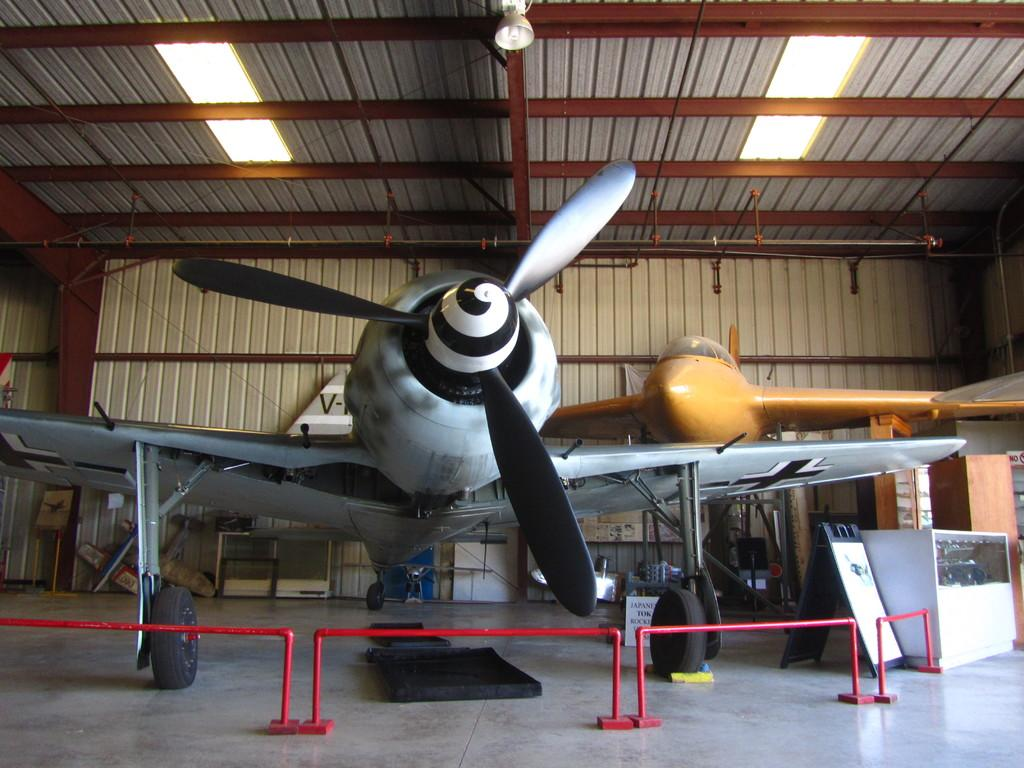What structure can be seen in the image? There is a shed in the image. What is inside the shed? There are two airplanes inside the shed. What feature is present in front of the shed? There is a railing in front of the shed. Where is the plot of land located in the image? There is no plot of land mentioned or visible in the image. What type of bed is present in the image? There is no bed present in the image. 